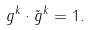<formula> <loc_0><loc_0><loc_500><loc_500>g ^ { k } \cdot \tilde { g } ^ { k } = 1 .</formula> 